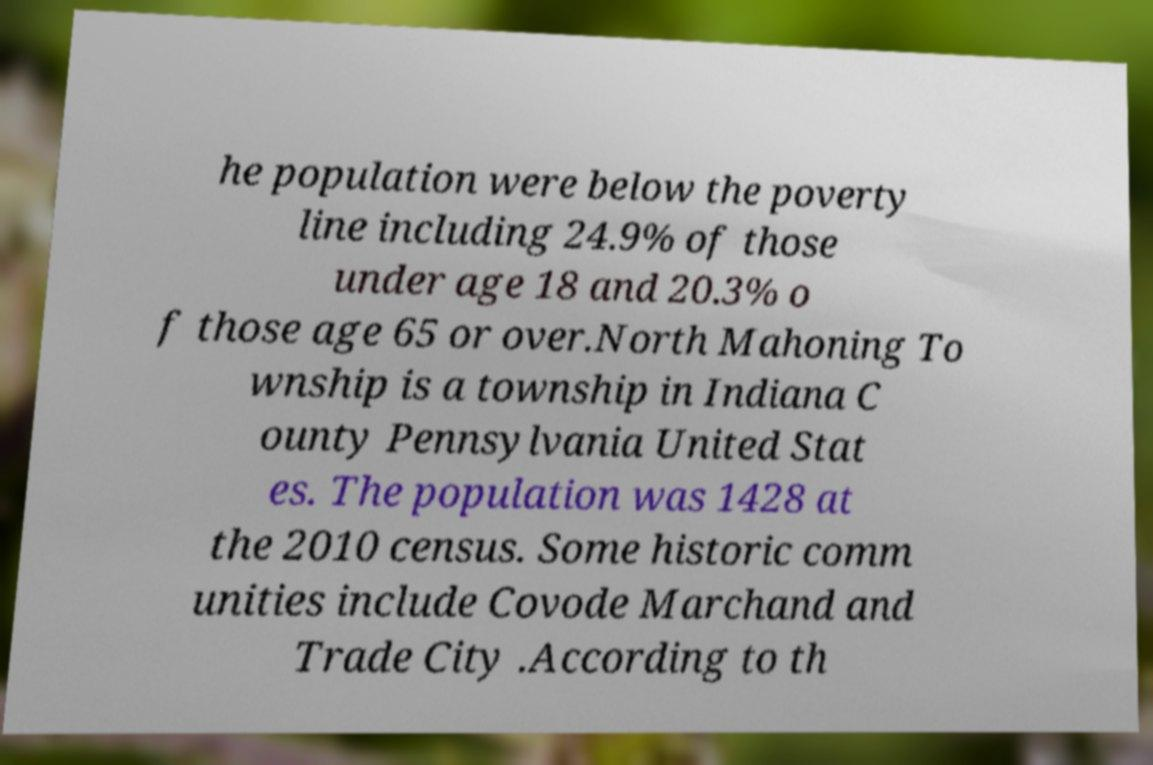For documentation purposes, I need the text within this image transcribed. Could you provide that? he population were below the poverty line including 24.9% of those under age 18 and 20.3% o f those age 65 or over.North Mahoning To wnship is a township in Indiana C ounty Pennsylvania United Stat es. The population was 1428 at the 2010 census. Some historic comm unities include Covode Marchand and Trade City .According to th 